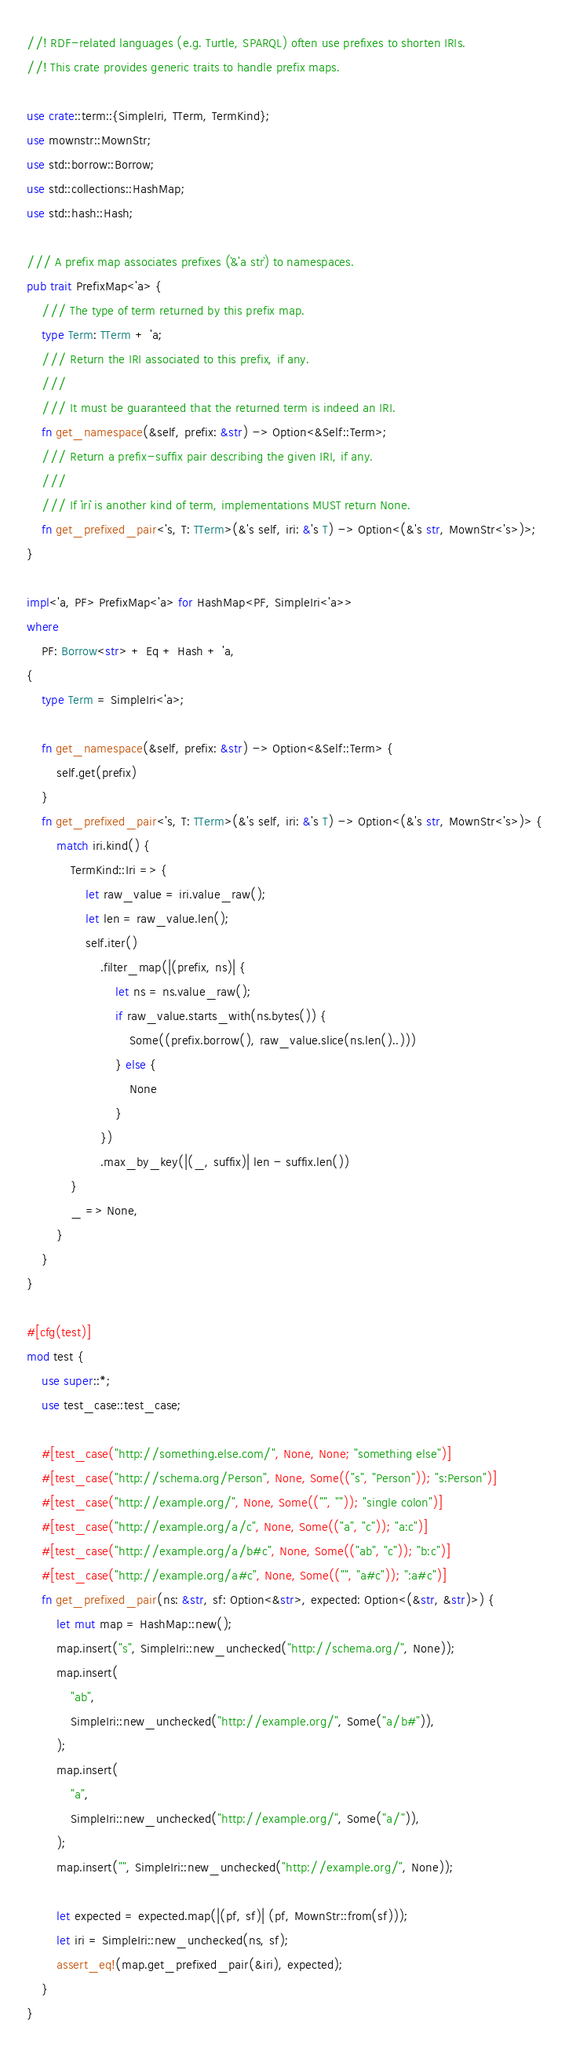<code> <loc_0><loc_0><loc_500><loc_500><_Rust_>//! RDF-related languages (e.g. Turtle, SPARQL) often use prefixes to shorten IRIs.
//! This crate provides generic traits to handle prefix maps.

use crate::term::{SimpleIri, TTerm, TermKind};
use mownstr::MownStr;
use std::borrow::Borrow;
use std::collections::HashMap;
use std::hash::Hash;

/// A prefix map associates prefixes (`&'a str`) to namespaces.
pub trait PrefixMap<'a> {
    /// The type of term returned by this prefix map.
    type Term: TTerm + 'a;
    /// Return the IRI associated to this prefix, if any.
    ///
    /// It must be guaranteed that the returned term is indeed an IRI.
    fn get_namespace(&self, prefix: &str) -> Option<&Self::Term>;
    /// Return a prefix-suffix pair describing the given IRI, if any.
    ///
    /// If `iri` is another kind of term, implementations MUST return None.
    fn get_prefixed_pair<'s, T: TTerm>(&'s self, iri: &'s T) -> Option<(&'s str, MownStr<'s>)>;
}

impl<'a, PF> PrefixMap<'a> for HashMap<PF, SimpleIri<'a>>
where
    PF: Borrow<str> + Eq + Hash + 'a,
{
    type Term = SimpleIri<'a>;

    fn get_namespace(&self, prefix: &str) -> Option<&Self::Term> {
        self.get(prefix)
    }
    fn get_prefixed_pair<'s, T: TTerm>(&'s self, iri: &'s T) -> Option<(&'s str, MownStr<'s>)> {
        match iri.kind() {
            TermKind::Iri => {
                let raw_value = iri.value_raw();
                let len = raw_value.len();
                self.iter()
                    .filter_map(|(prefix, ns)| {
                        let ns = ns.value_raw();
                        if raw_value.starts_with(ns.bytes()) {
                            Some((prefix.borrow(), raw_value.slice(ns.len()..)))
                        } else {
                            None
                        }
                    })
                    .max_by_key(|(_, suffix)| len - suffix.len())
            }
            _ => None,
        }
    }
}

#[cfg(test)]
mod test {
    use super::*;
    use test_case::test_case;

    #[test_case("http://something.else.com/", None, None; "something else")]
    #[test_case("http://schema.org/Person", None, Some(("s", "Person")); "s:Person")]
    #[test_case("http://example.org/", None, Some(("", "")); "single colon")]
    #[test_case("http://example.org/a/c", None, Some(("a", "c")); "a:c")]
    #[test_case("http://example.org/a/b#c", None, Some(("ab", "c")); "b:c")]
    #[test_case("http://example.org/a#c", None, Some(("", "a#c")); ":a#c")]
    fn get_prefixed_pair(ns: &str, sf: Option<&str>, expected: Option<(&str, &str)>) {
        let mut map = HashMap::new();
        map.insert("s", SimpleIri::new_unchecked("http://schema.org/", None));
        map.insert(
            "ab",
            SimpleIri::new_unchecked("http://example.org/", Some("a/b#")),
        );
        map.insert(
            "a",
            SimpleIri::new_unchecked("http://example.org/", Some("a/")),
        );
        map.insert("", SimpleIri::new_unchecked("http://example.org/", None));

        let expected = expected.map(|(pf, sf)| (pf, MownStr::from(sf)));
        let iri = SimpleIri::new_unchecked(ns, sf);
        assert_eq!(map.get_prefixed_pair(&iri), expected);
    }
}
</code> 